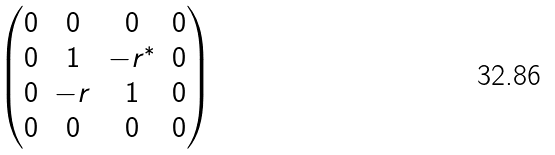<formula> <loc_0><loc_0><loc_500><loc_500>\begin{pmatrix} 0 & 0 & 0 & 0 \\ 0 & 1 & - r ^ { * } & 0 \\ 0 & - r & 1 & 0 \\ 0 & 0 & 0 & 0 \end{pmatrix}</formula> 